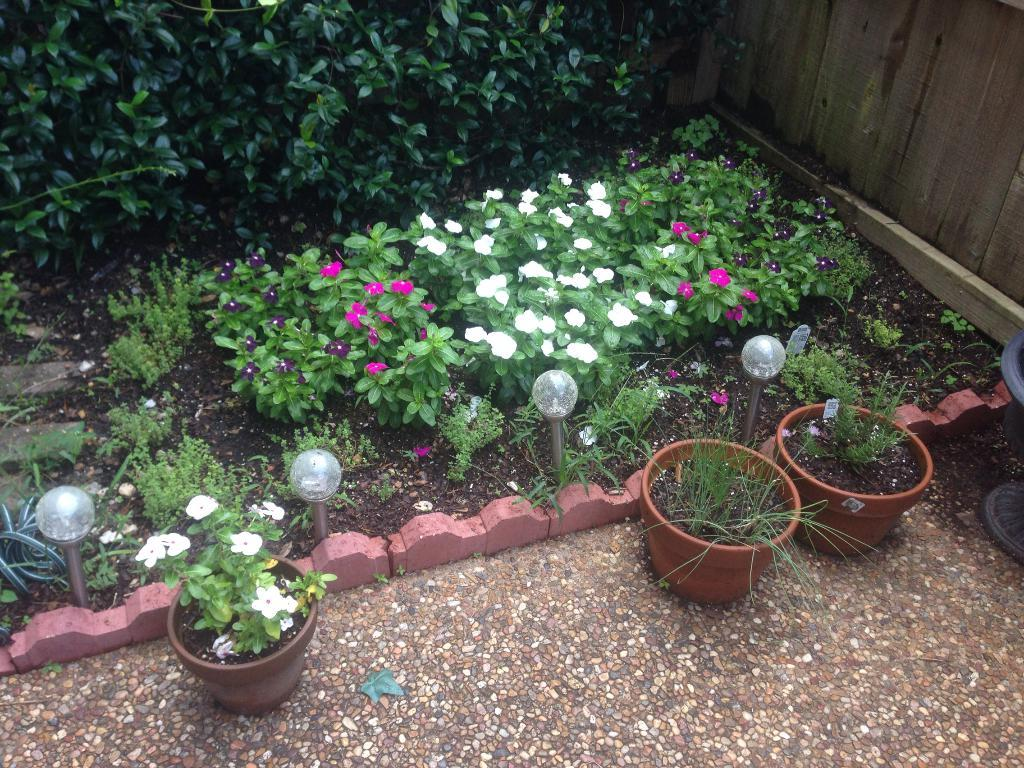What can be seen in the foreground of the image? In the foreground of the image, there are plants in pots and light poles. What is visible in the background of the image? In the background of the image, there is a group of flowers on plants, trees, and a wooden fence. How many plants in pots are in the foreground? The number of plants in pots is not specified, so it cannot be determined from the image. What type of crowd can be seen gathering around the church in the image? There is no church or crowd present in the image. How many flowers are in the group of flowers in the background? The number of flowers in the group is not specified, so it cannot be determined from the image. 